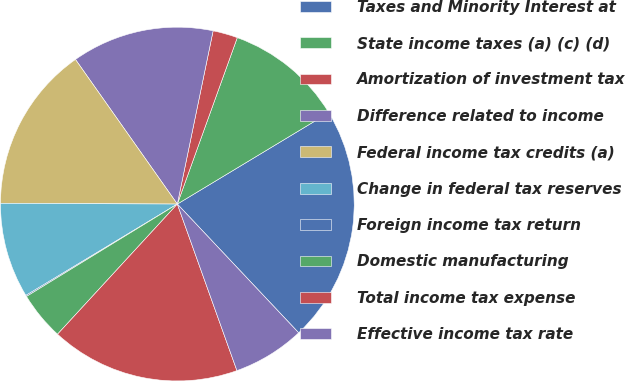Convert chart. <chart><loc_0><loc_0><loc_500><loc_500><pie_chart><fcel>Taxes and Minority Interest at<fcel>State income taxes (a) (c) (d)<fcel>Amortization of investment tax<fcel>Difference related to income<fcel>Federal income tax credits (a)<fcel>Change in federal tax reserves<fcel>Foreign income tax return<fcel>Domestic manufacturing<fcel>Total income tax expense<fcel>Effective income tax rate<nl><fcel>21.61%<fcel>10.86%<fcel>2.26%<fcel>13.01%<fcel>15.16%<fcel>8.71%<fcel>0.11%<fcel>4.41%<fcel>17.31%<fcel>6.56%<nl></chart> 